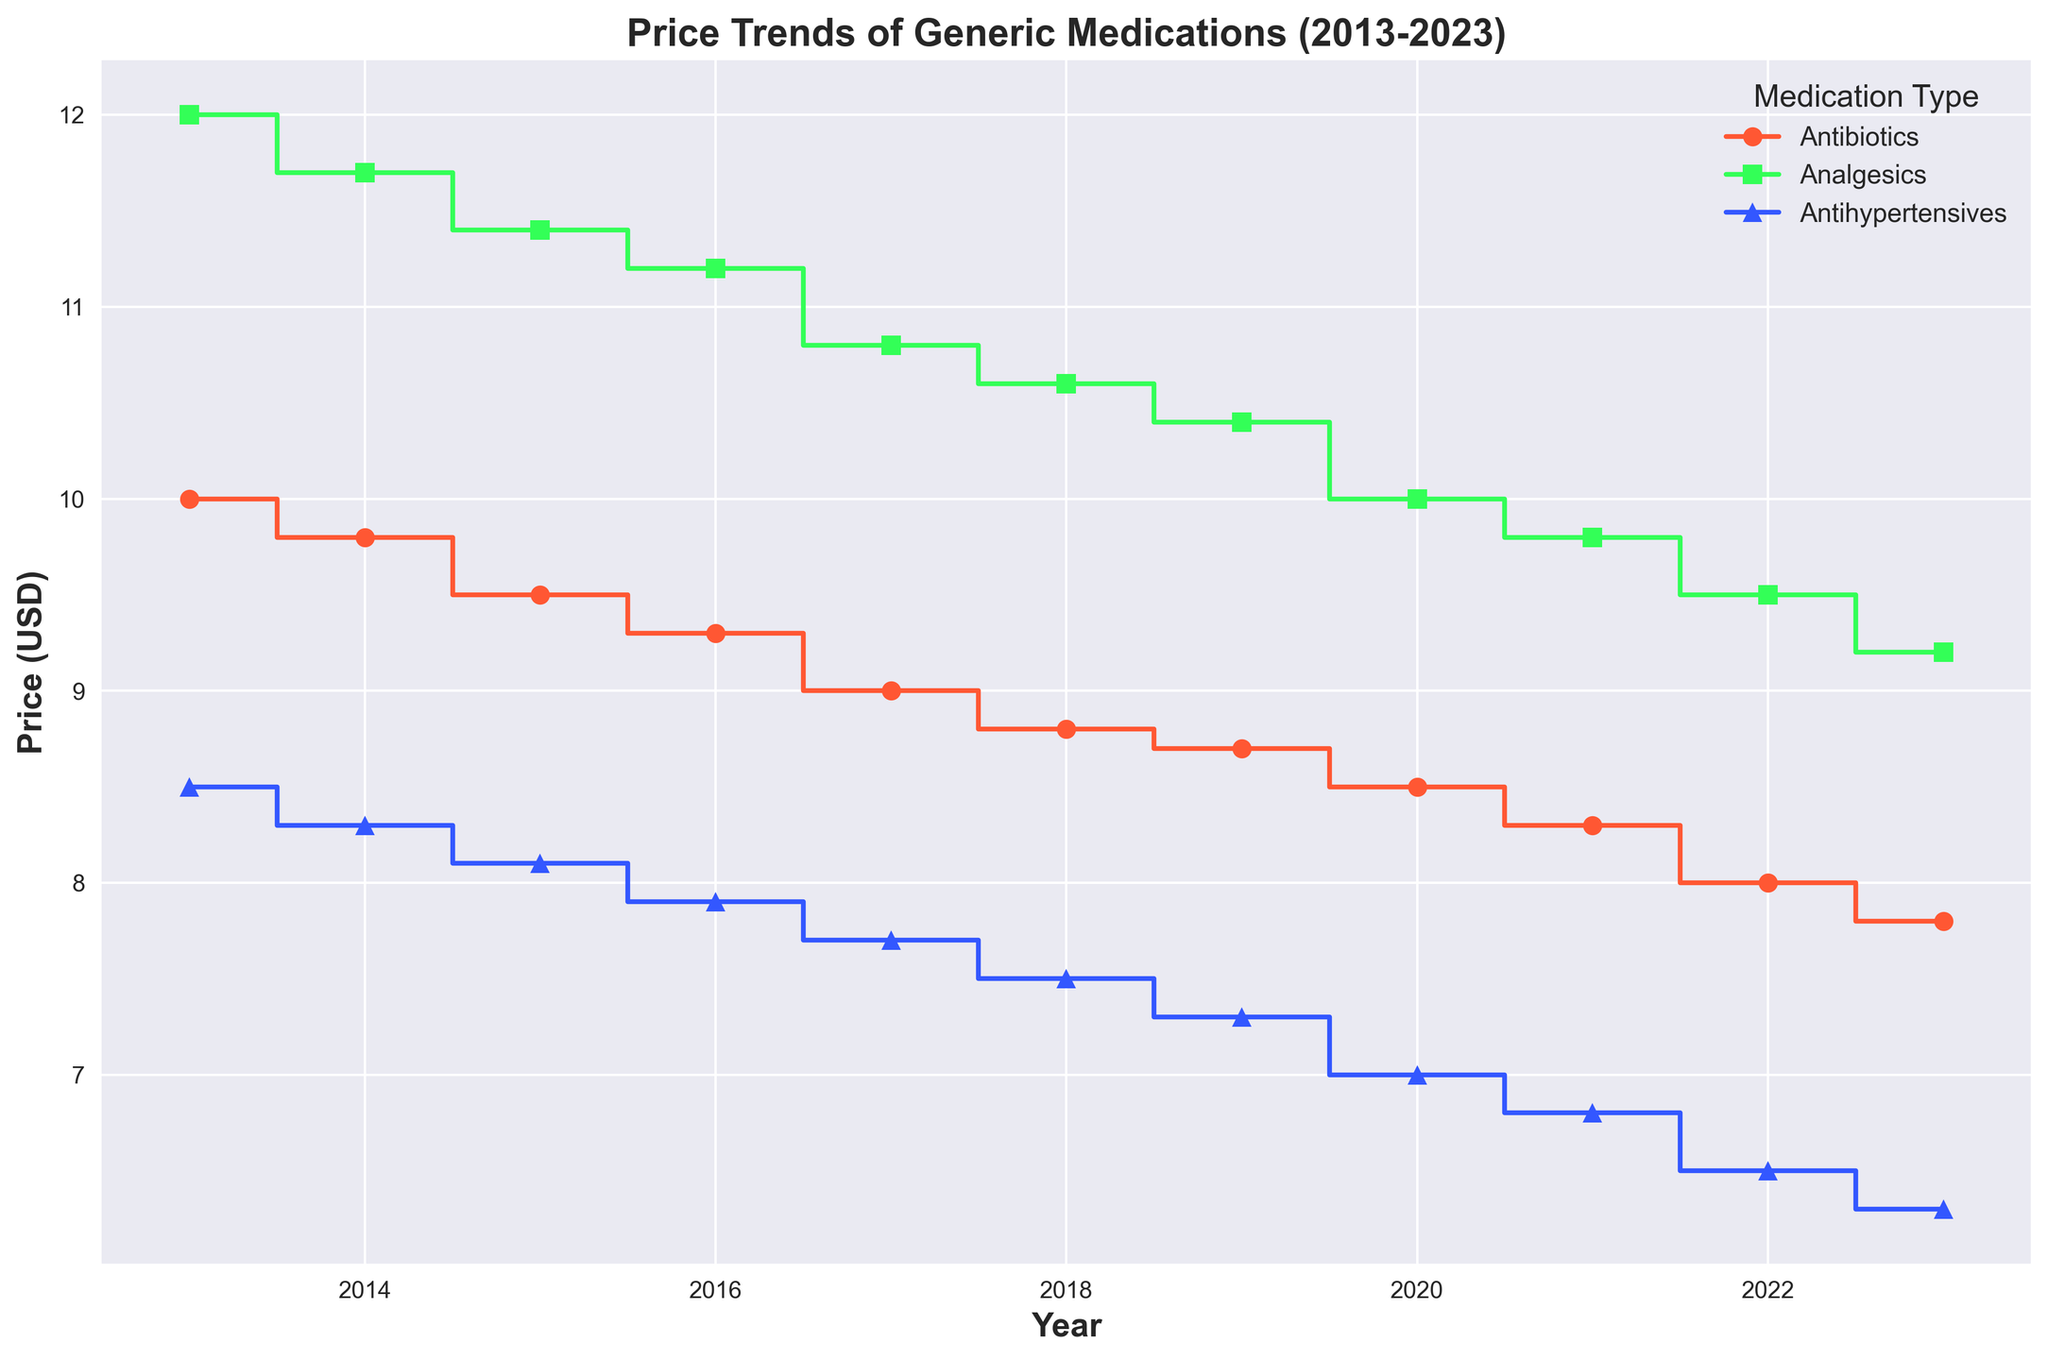Which medication type had the most constant price trend over the decade? By observing the steps in the lines, we can determine that Analgesics had the smallest price decreases each year, indicating a more constant trend compared to large drops in Antibiotics and Antihypertensives.
Answer: Analgesics Which medication type experienced the largest price drop from 2013 to 2023? Analyzing the price trends, Antihypertensives dropped from 8.5 in 2013 to 6.3 in 2023, which is a 2.2 decrease, larger than both Antibiotics (2.2) and Analgesics (2.8).
Answer: Antihypertensives In which year did Analgesics have the smallest decrease in price compared to the previous year? By tracking the segments of the Analgesics line, in 2019 the price dropped from 10.6 in 2018 to 10.4 in 2019 making it the smallest change of 0.2.
Answer: 2019 How much did the price of Antibiotics decrease during the entire decade? Looking at the 2013 price of 10.0 and comparing it to the 2023 price of 7.8, the decrease is 10.0 - 7.8 = 2.2.
Answer: 2.2 How many times did the Antibiotics price drop over the decade? Each step down in the Antibiotics line represents a drop, counting those gives a total of 10 drops.
Answer: 10 Which medication type had the highest price in 2015? By comparing the heights of the lines in 2015, Analgesics were priced highest at 11.4.
Answer: Analgesics Did the prices of Antihypertensives decrease consistently each year? The Antihypertensives line shows consistent declines each year without any increases or stability, indicating a consistent downward trend.
Answer: Yes By how much did the price of Analgesics decrease from 2013 to 2020? Analgesics were priced at 12.0 in 2013 and 10.0 in 2020; therefore, the decrease is 12.0 - 10.0 = 2.0.
Answer: 2.0 